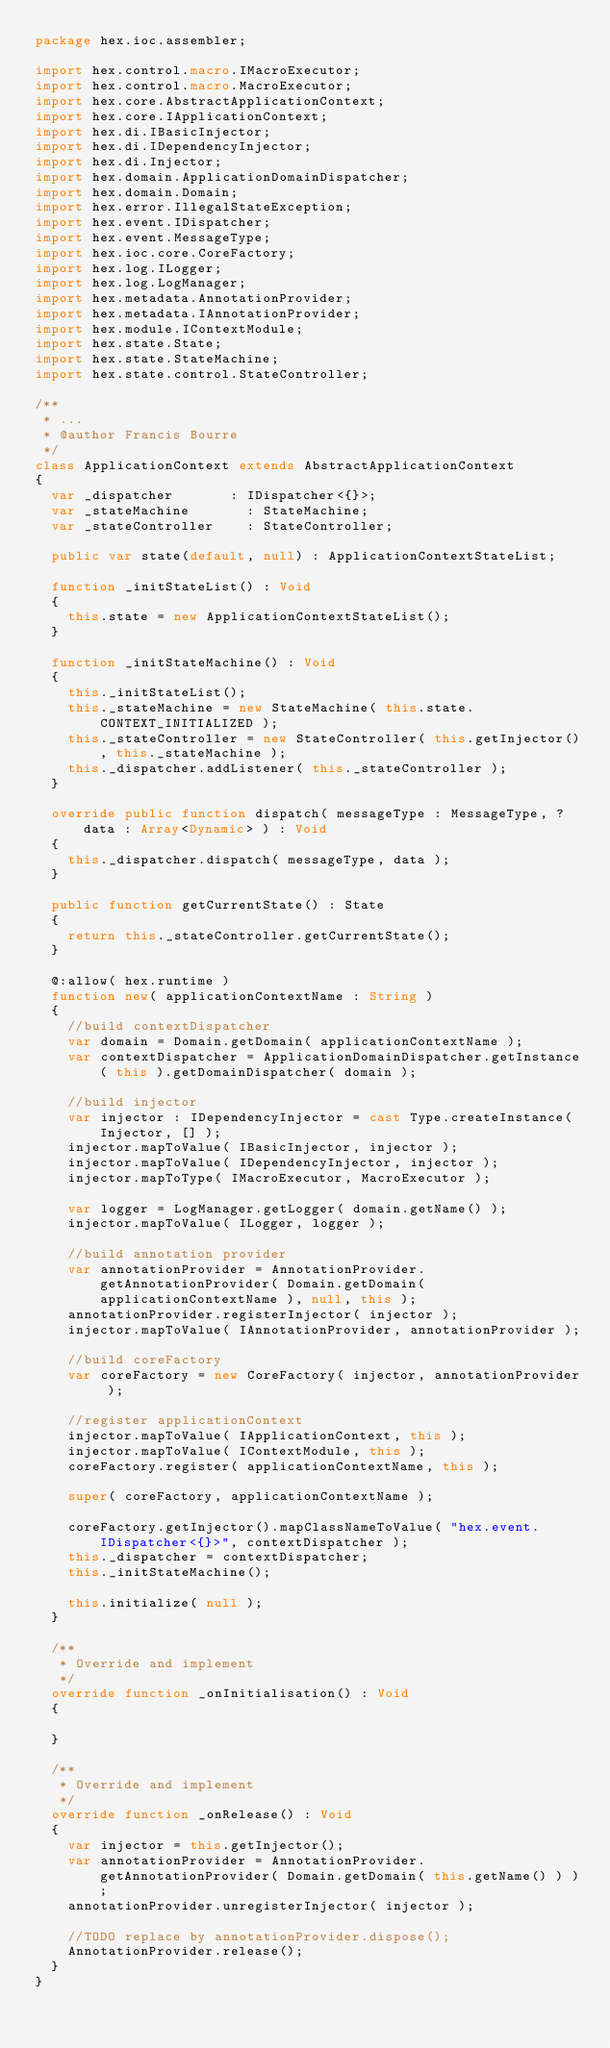<code> <loc_0><loc_0><loc_500><loc_500><_Haxe_>package hex.ioc.assembler;

import hex.control.macro.IMacroExecutor;
import hex.control.macro.MacroExecutor;
import hex.core.AbstractApplicationContext;
import hex.core.IApplicationContext;
import hex.di.IBasicInjector;
import hex.di.IDependencyInjector;
import hex.di.Injector;
import hex.domain.ApplicationDomainDispatcher;
import hex.domain.Domain;
import hex.error.IllegalStateException;
import hex.event.IDispatcher;
import hex.event.MessageType;
import hex.ioc.core.CoreFactory;
import hex.log.ILogger;
import hex.log.LogManager;
import hex.metadata.AnnotationProvider;
import hex.metadata.IAnnotationProvider;
import hex.module.IContextModule;
import hex.state.State;
import hex.state.StateMachine;
import hex.state.control.StateController;

/**
 * ...
 * @author Francis Bourre
 */
class ApplicationContext extends AbstractApplicationContext
{
	var _dispatcher 			: IDispatcher<{}>;
	var _stateMachine 			: StateMachine;
	var _stateController 		: StateController;
	
	public var state(default, null) : ApplicationContextStateList;
	
	function _initStateList() : Void
	{
		this.state = new ApplicationContextStateList();
	}
	
	function _initStateMachine() : Void
	{
		this._initStateList();
		this._stateMachine = new StateMachine( this.state.CONTEXT_INITIALIZED );
		this._stateController = new StateController( this.getInjector(), this._stateMachine );
		this._dispatcher.addListener( this._stateController );
	}
	
	override public function dispatch( messageType : MessageType, ?data : Array<Dynamic> ) : Void
	{
		this._dispatcher.dispatch( messageType, data );
	}
	
	public function getCurrentState() : State
	{
		return this._stateController.getCurrentState();
	}
	
	@:allow( hex.runtime )
	function new( applicationContextName : String )
	{
		//build contextDispatcher
		var domain = Domain.getDomain( applicationContextName );
		var contextDispatcher = ApplicationDomainDispatcher.getInstance( this ).getDomainDispatcher( domain );
		
		//build injector
		var injector : IDependencyInjector = cast Type.createInstance( Injector, [] );
		injector.mapToValue( IBasicInjector, injector );
		injector.mapToValue( IDependencyInjector, injector );
		injector.mapToType( IMacroExecutor, MacroExecutor );
		
		var logger = LogManager.getLogger( domain.getName() );
		injector.mapToValue( ILogger, logger );
		
		//build annotation provider
		var annotationProvider = AnnotationProvider.getAnnotationProvider( Domain.getDomain( applicationContextName ), null, this );
		annotationProvider.registerInjector( injector );
		injector.mapToValue( IAnnotationProvider, annotationProvider );
		
		//build coreFactory
		var coreFactory = new CoreFactory( injector, annotationProvider );
		
		//register applicationContext
		injector.mapToValue( IApplicationContext, this );
		injector.mapToValue( IContextModule, this );
		coreFactory.register( applicationContextName, this );
		
		super( coreFactory, applicationContextName );
		
		coreFactory.getInjector().mapClassNameToValue( "hex.event.IDispatcher<{}>", contextDispatcher );
		this._dispatcher = contextDispatcher;
		this._initStateMachine();
		
		this.initialize( null );
	}
	
	/**
	 * Override and implement
	 */
	override function _onInitialisation() : Void
	{

	}

	/**
	 * Override and implement
	 */
	override function _onRelease() : Void
	{
		var injector = this.getInjector();
		var annotationProvider = AnnotationProvider.getAnnotationProvider( Domain.getDomain( this.getName() ) );
		annotationProvider.unregisterInjector( injector );
		
		//TODO replace by annotationProvider.dispose();
		AnnotationProvider.release();
	}
}</code> 